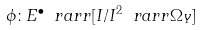<formula> <loc_0><loc_0><loc_500><loc_500>\phi \colon E ^ { \bullet } \ r a r r [ I / I ^ { 2 } \ r a r r \Omega _ { Y } ]</formula> 